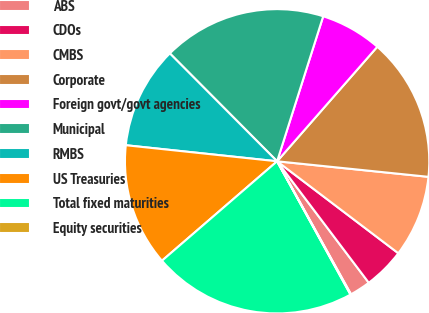Convert chart. <chart><loc_0><loc_0><loc_500><loc_500><pie_chart><fcel>ABS<fcel>CDOs<fcel>CMBS<fcel>Corporate<fcel>Foreign govt/govt agencies<fcel>Municipal<fcel>RMBS<fcel>US Treasuries<fcel>Total fixed maturities<fcel>Equity securities<nl><fcel>2.22%<fcel>4.38%<fcel>8.7%<fcel>15.19%<fcel>6.54%<fcel>17.35%<fcel>10.86%<fcel>13.02%<fcel>21.67%<fcel>0.06%<nl></chart> 